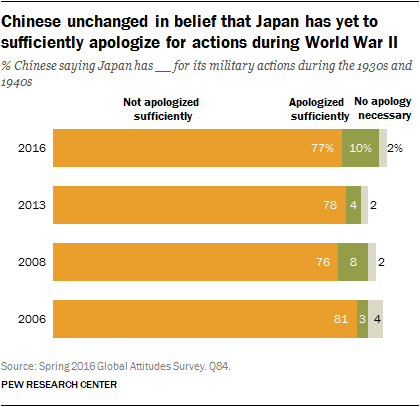What does the 'Don't know/Refused to answer' category tell us about the survey population's views? The 'Don't know/Refused to answer' category, represented by the gray color in the graph, indicates that a small percentage of the survey population either is not sure about their stance on Japan's apologies, or chose not to disclose their opinion. This might reflect uncertainty or indifference on the subject or a reluctance to discuss sensitive historical issues. 